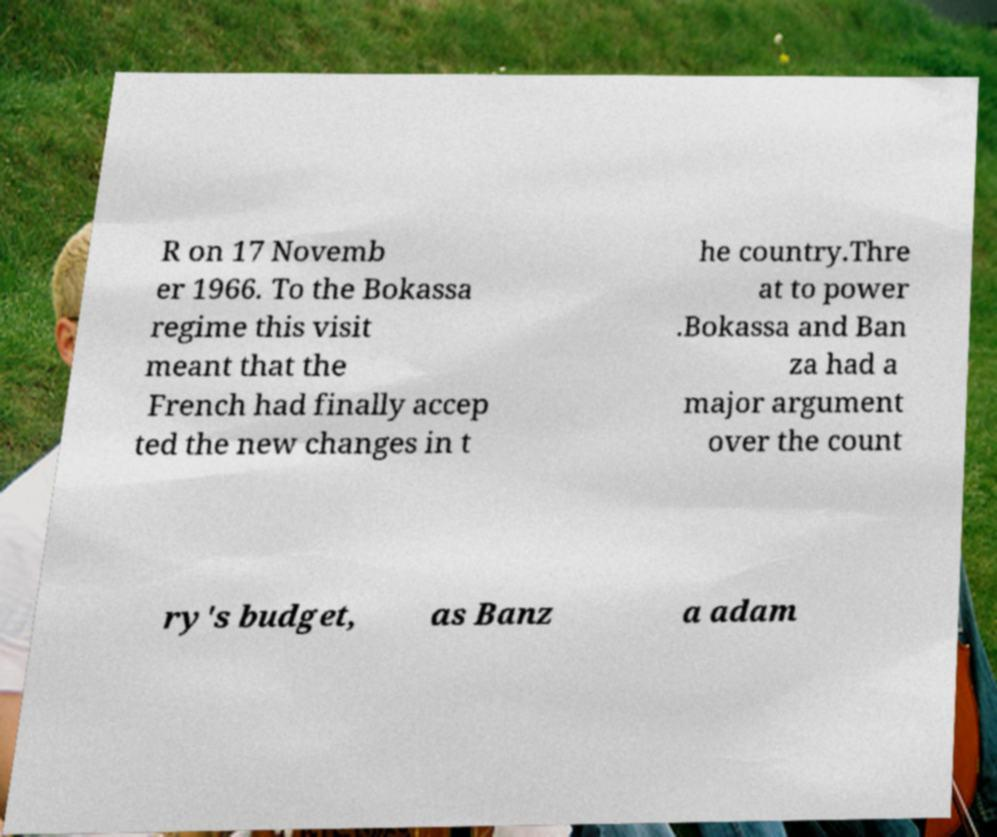Could you assist in decoding the text presented in this image and type it out clearly? R on 17 Novemb er 1966. To the Bokassa regime this visit meant that the French had finally accep ted the new changes in t he country.Thre at to power .Bokassa and Ban za had a major argument over the count ry's budget, as Banz a adam 